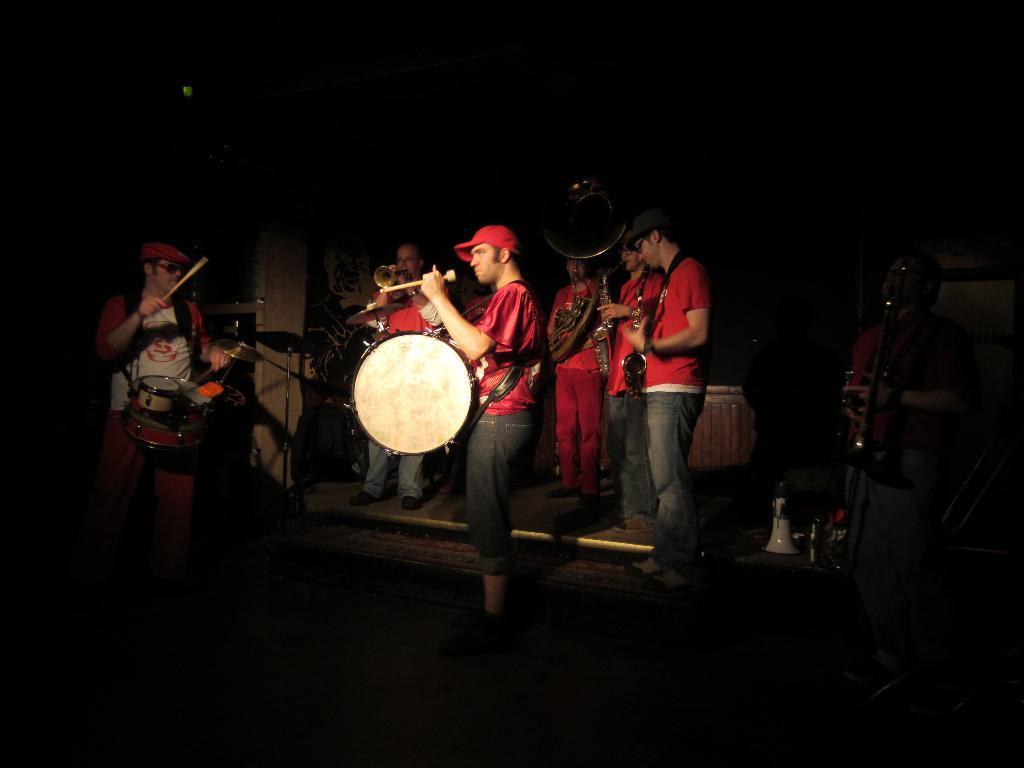Can you describe this image briefly? In this image there are group of persons standing and playing musical instruments. 